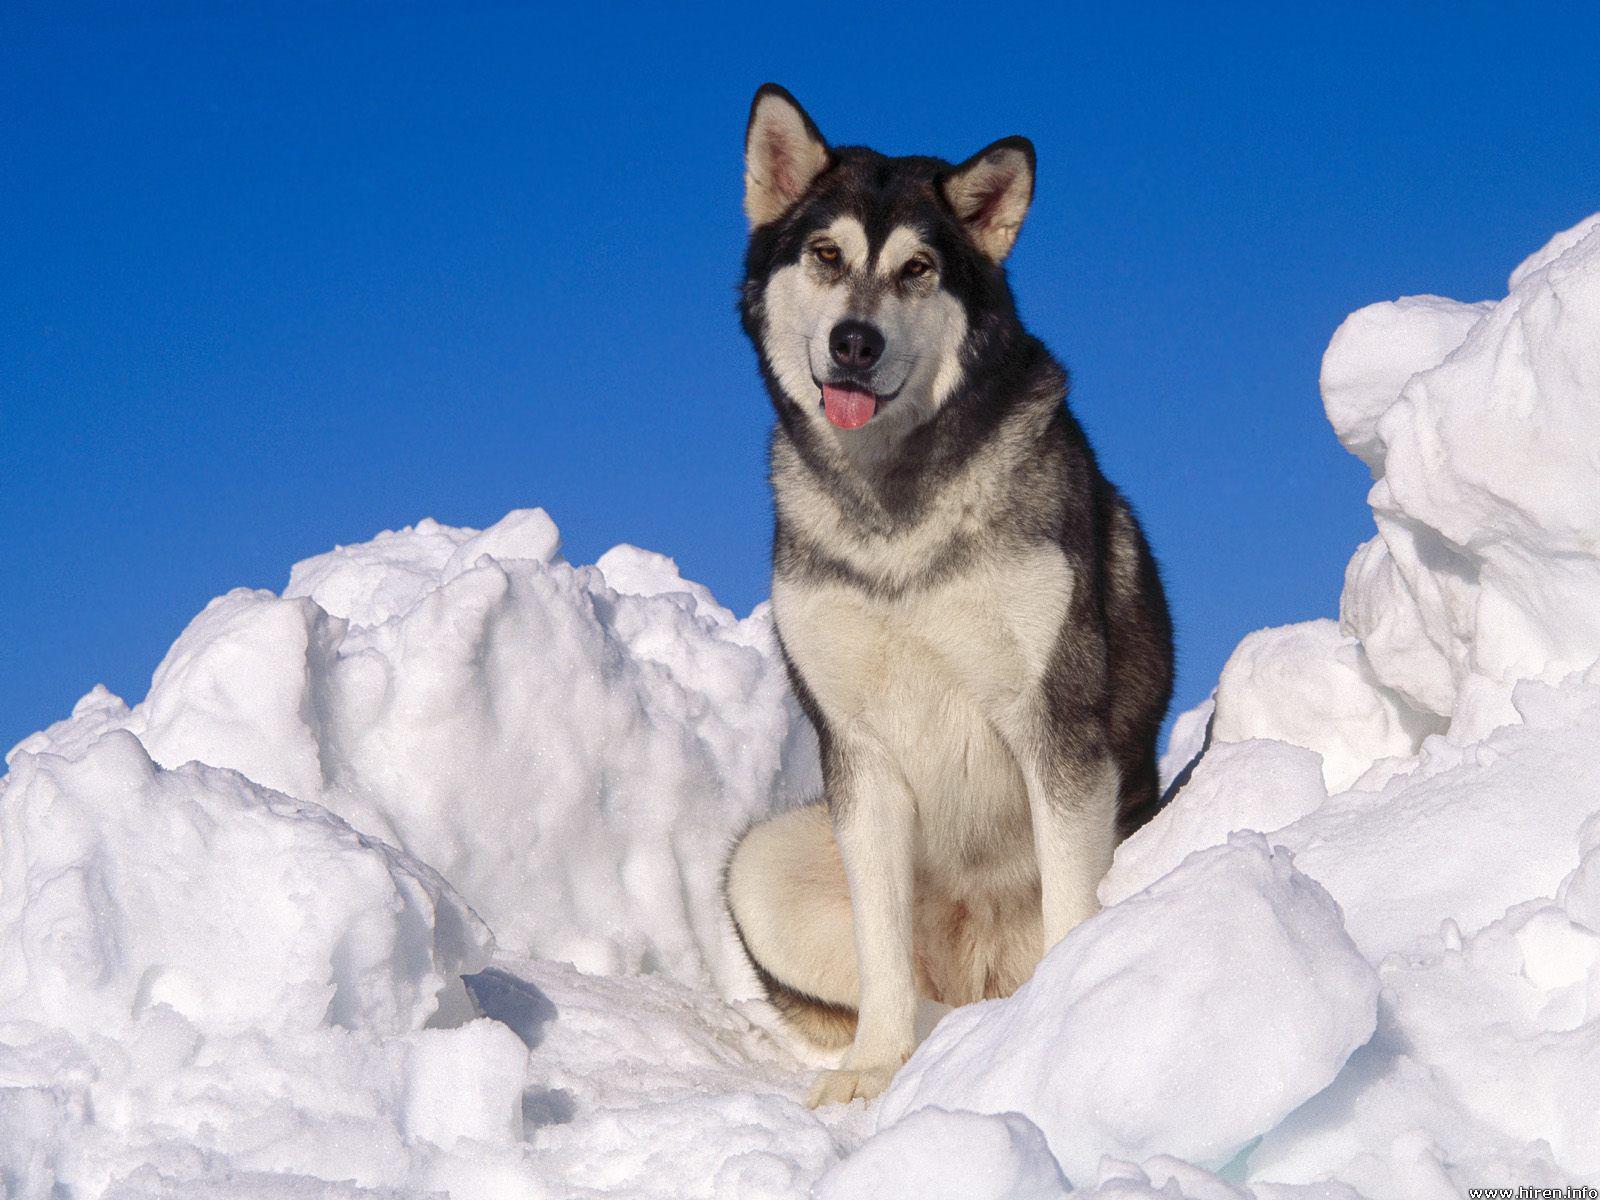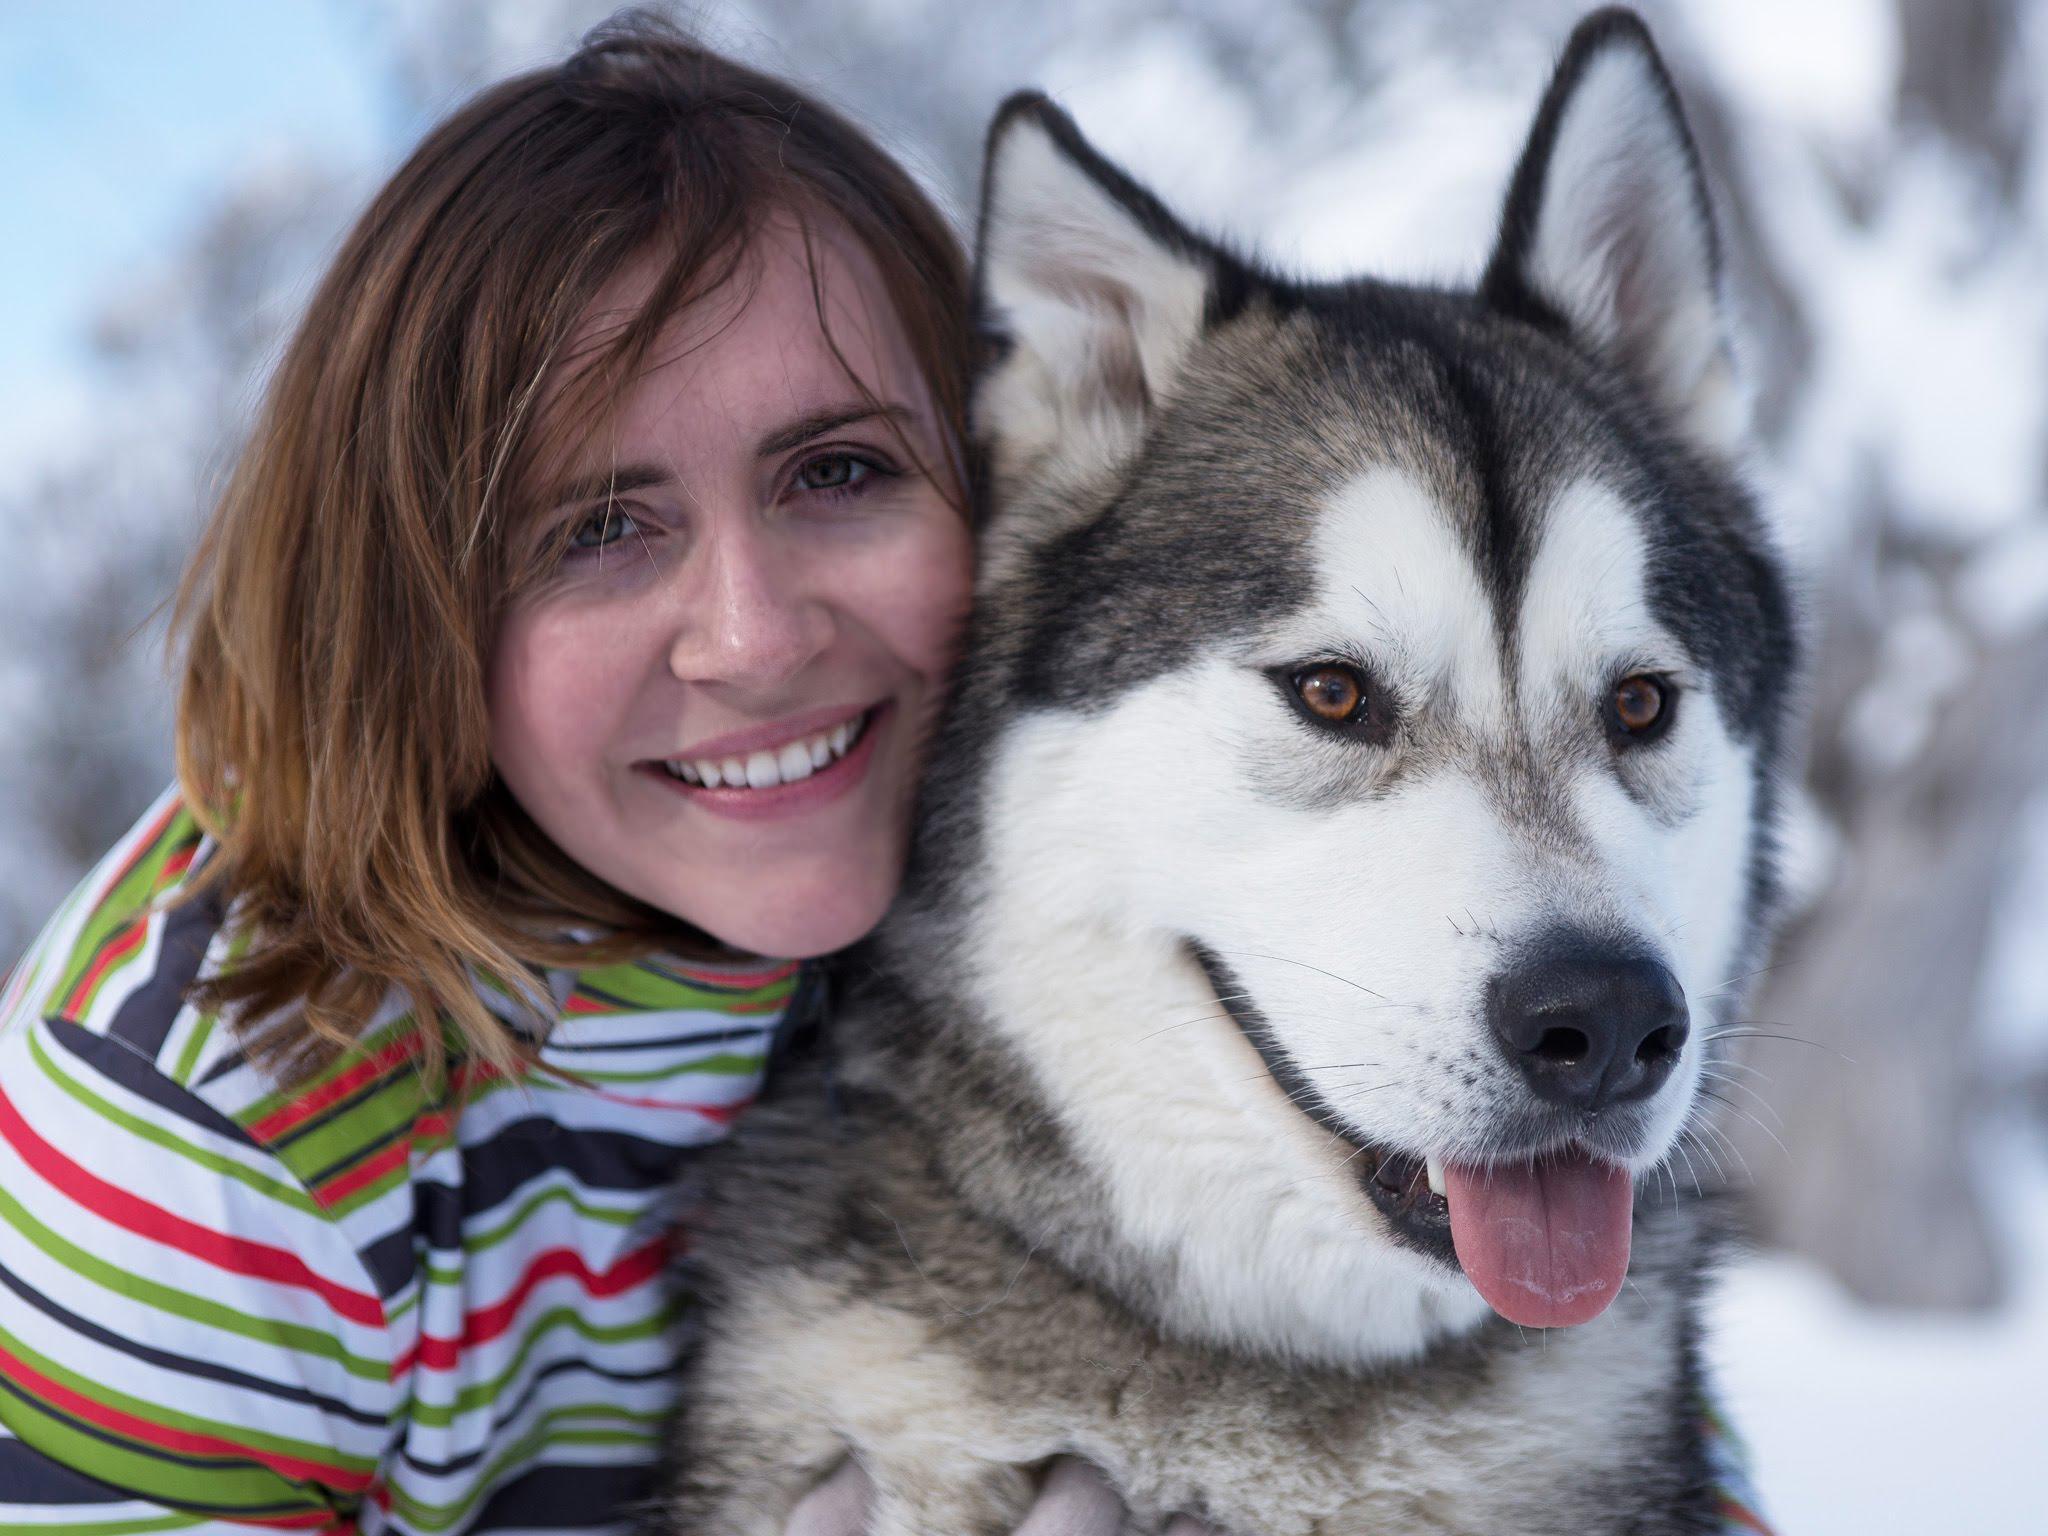The first image is the image on the left, the second image is the image on the right. Examine the images to the left and right. Is the description "There are at most three dogs in total." accurate? Answer yes or no. Yes. The first image is the image on the left, the second image is the image on the right. Assess this claim about the two images: "One of the images contains exactly two dogs.". Correct or not? Answer yes or no. No. 